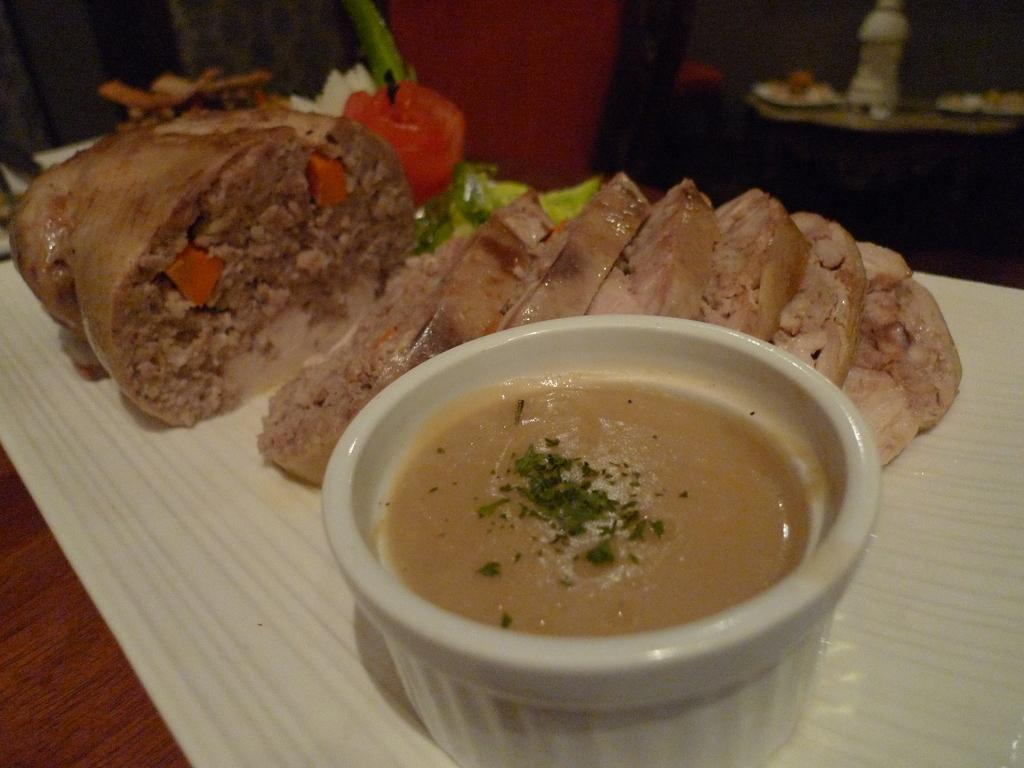What type of surface is visible in the image? There is a wooden surface in the image. What is placed on the wooden surface? There is a bowl and a container on the wooden surface. Can you describe any other objects in the image? There is a bottle in the image. How would you describe the background of the image? The background of the image is blurred. What type of treatment is being administered in the image? There is no treatment being administered in the image; it only features a wooden surface with a bowl, container, and bottle. Can you describe the picture hanging on the wall in the image? There is no picture hanging on the wall in the image. What time is displayed on the clock in the image? There is no clock present in the image. 